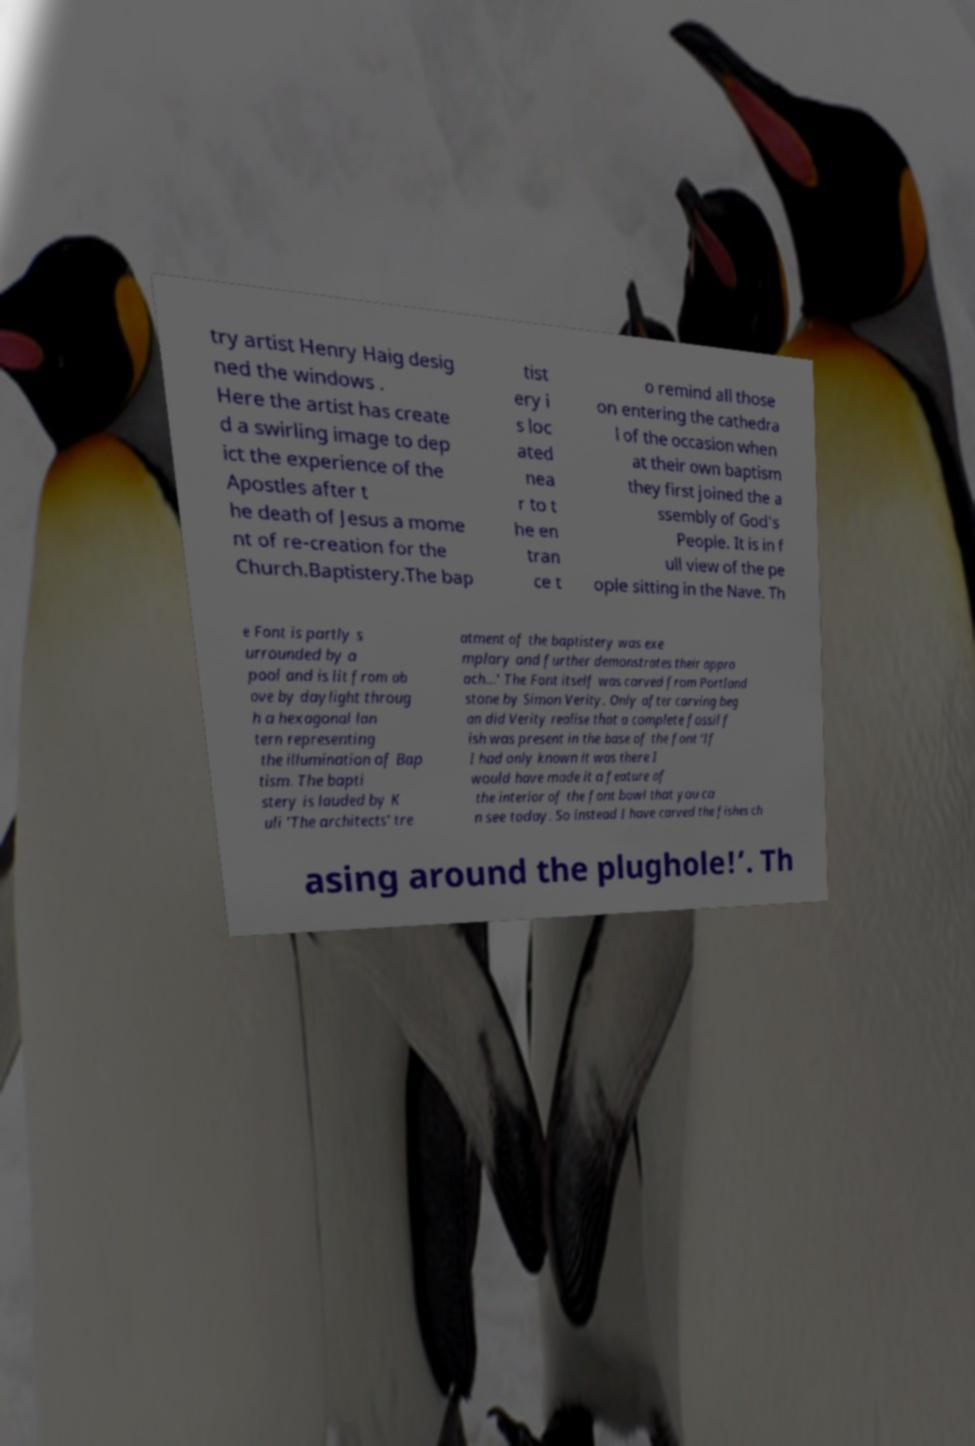Please read and relay the text visible in this image. What does it say? try artist Henry Haig desig ned the windows . Here the artist has create d a swirling image to dep ict the experience of the Apostles after t he death of Jesus a mome nt of re-creation for the Church.Baptistery.The bap tist ery i s loc ated nea r to t he en tran ce t o remind all those on entering the cathedra l of the occasion when at their own baptism they first joined the a ssembly of God's People. It is in f ull view of the pe ople sitting in the Nave. Th e Font is partly s urrounded by a pool and is lit from ab ove by daylight throug h a hexagonal lan tern representing the illumination of Bap tism. The bapti stery is lauded by K uli 'The architects' tre atment of the baptistery was exe mplary and further demonstrates their appro ach...' The Font itself was carved from Portland stone by Simon Verity. Only after carving beg an did Verity realise that a complete fossil f ish was present in the base of the font ‘If I had only known it was there I would have made it a feature of the interior of the font bowl that you ca n see today. So instead I have carved the fishes ch asing around the plughole!’. Th 